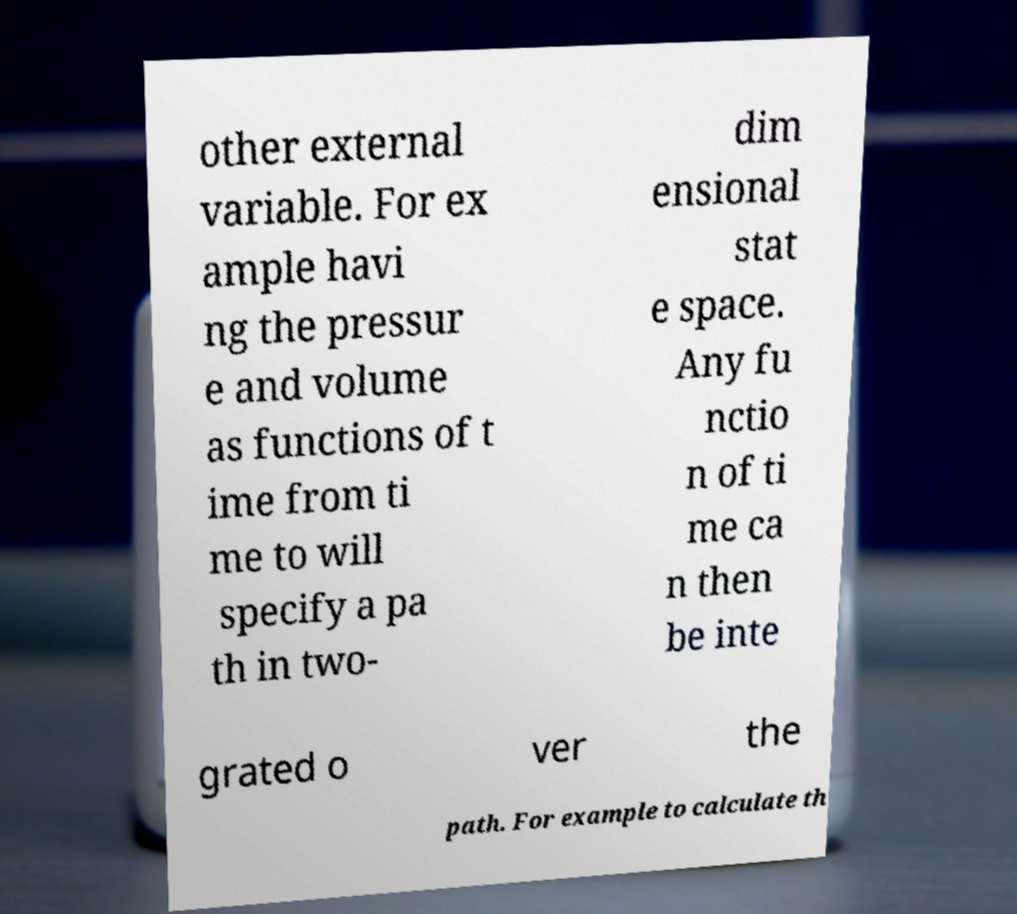Please read and relay the text visible in this image. What does it say? other external variable. For ex ample havi ng the pressur e and volume as functions of t ime from ti me to will specify a pa th in two- dim ensional stat e space. Any fu nctio n of ti me ca n then be inte grated o ver the path. For example to calculate th 